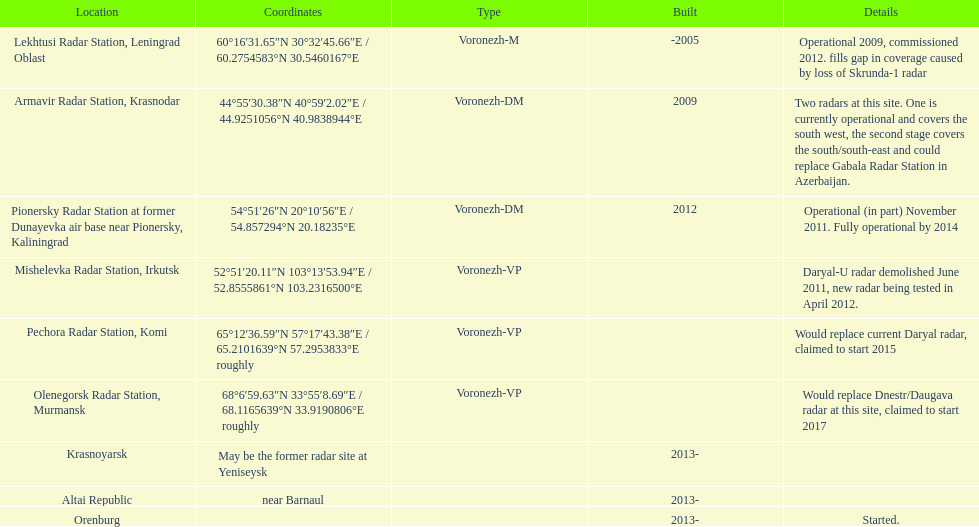In which year was the top built? -2005. 